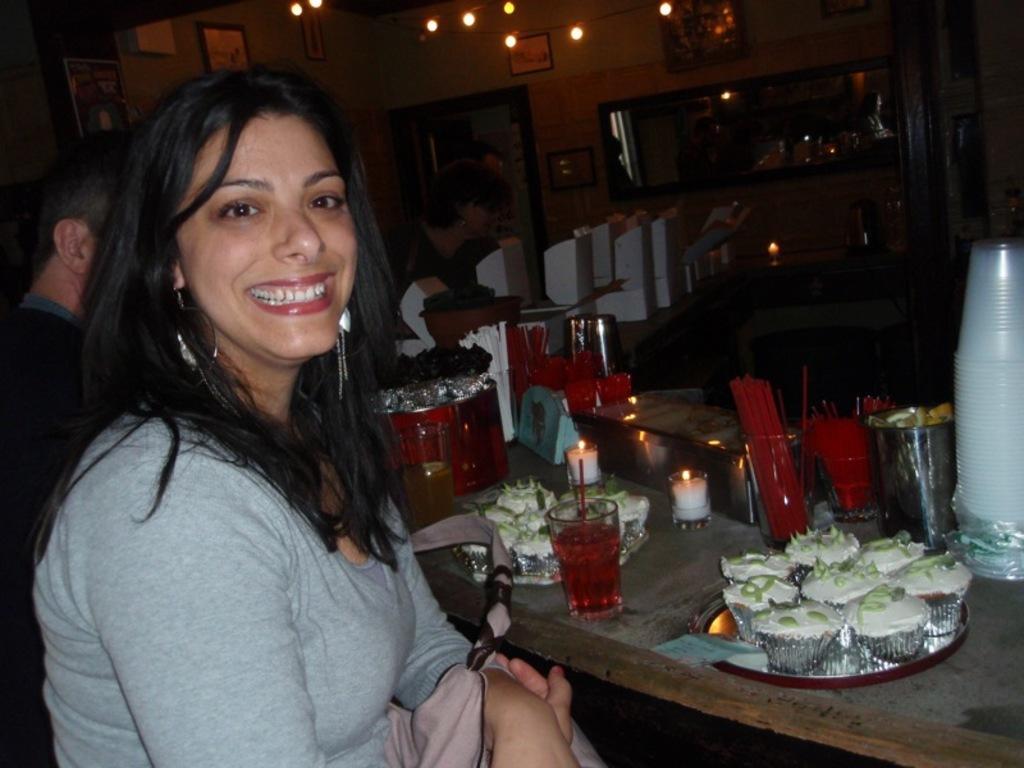Describe this image in one or two sentences. In the image there is a woman in grey t-shirt sitting in front of table with cupcakes,water glasses and juice glasses with straws on it and beside her there is another person visible, in the back there are chairs and lights over the ceiling with photographs on the wall. 